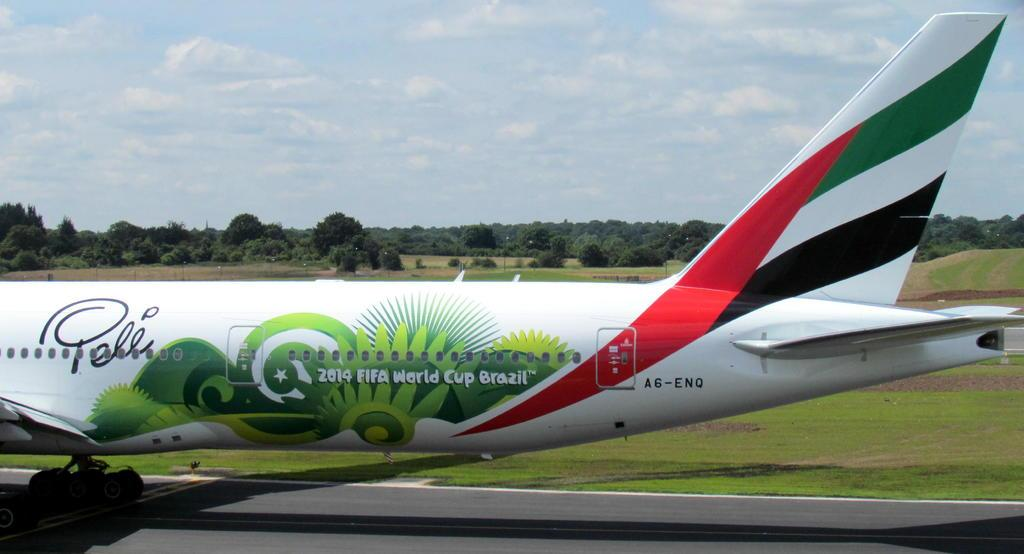What is the unusual object on the road in the image? There is an aeroplane on the road in the image. What can be seen in the distance in the image? There are poles, trees, and grassy land in the background of the image. What is the condition of the sky in the image? The sky is covered with clouds in the image. What type of button can be seen on the aeroplane in the image? There is no button visible on the aeroplane in the image. How does the aeroplane look in detail in the image? The image does not provide a detailed view of the aeroplane; it only shows the aeroplane on the road. 